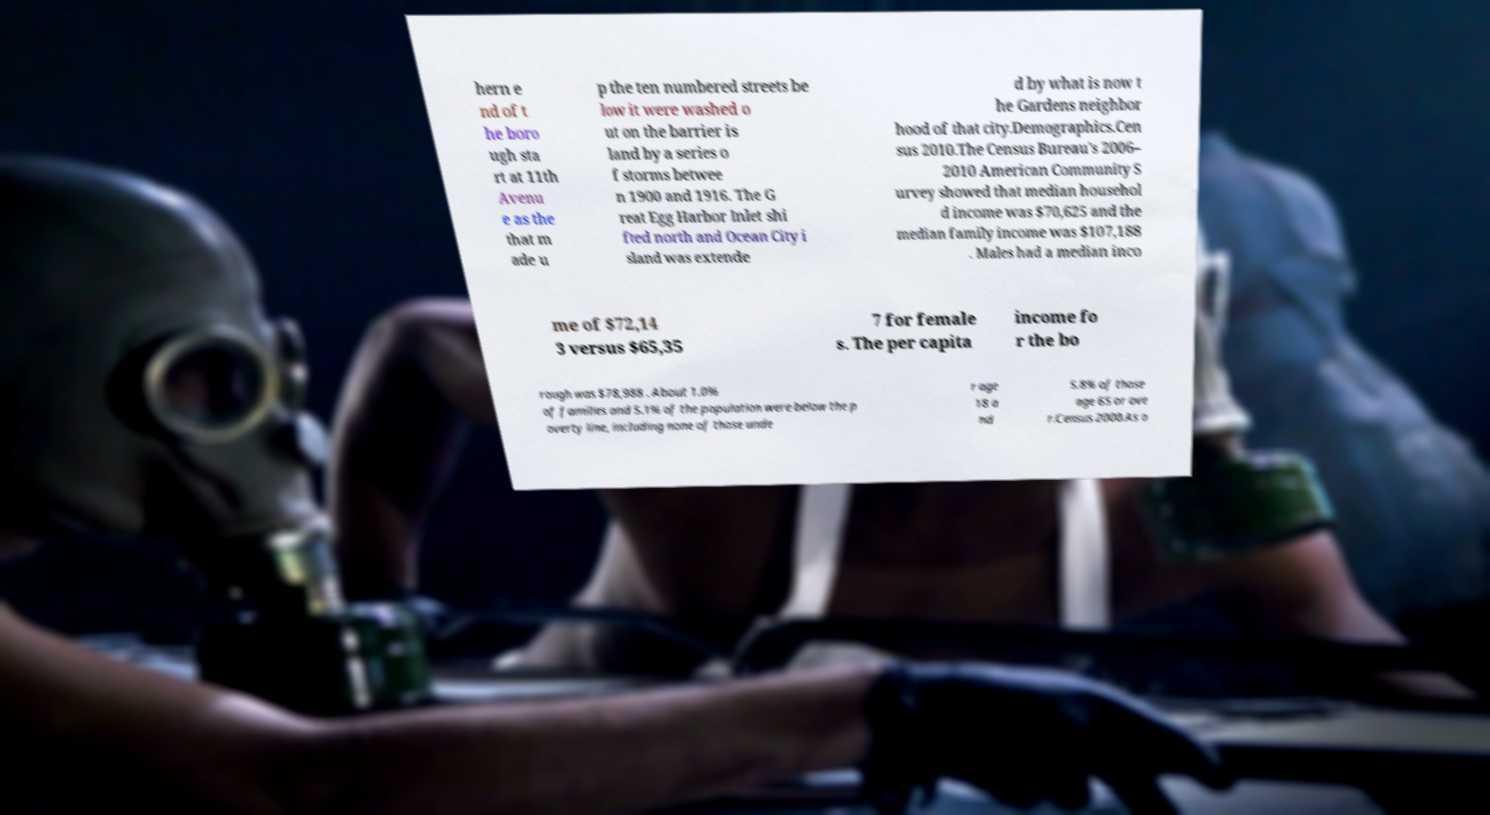There's text embedded in this image that I need extracted. Can you transcribe it verbatim? hern e nd of t he boro ugh sta rt at 11th Avenu e as the that m ade u p the ten numbered streets be low it were washed o ut on the barrier is land by a series o f storms betwee n 1900 and 1916. The G reat Egg Harbor Inlet shi fted north and Ocean City i sland was extende d by what is now t he Gardens neighbor hood of that city.Demographics.Cen sus 2010.The Census Bureau's 2006– 2010 American Community S urvey showed that median househol d income was $70,625 and the median family income was $107,188 . Males had a median inco me of $72,14 3 versus $65,35 7 for female s. The per capita income fo r the bo rough was $78,988 . About 1.0% of families and 5.1% of the population were below the p overty line, including none of those unde r age 18 a nd 5.8% of those age 65 or ove r.Census 2000.As o 